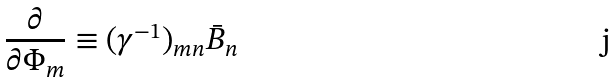Convert formula to latex. <formula><loc_0><loc_0><loc_500><loc_500>\frac { \partial } { \partial \Phi _ { m } } \equiv ( \gamma ^ { - 1 } ) _ { m n } \bar { B } _ { n }</formula> 